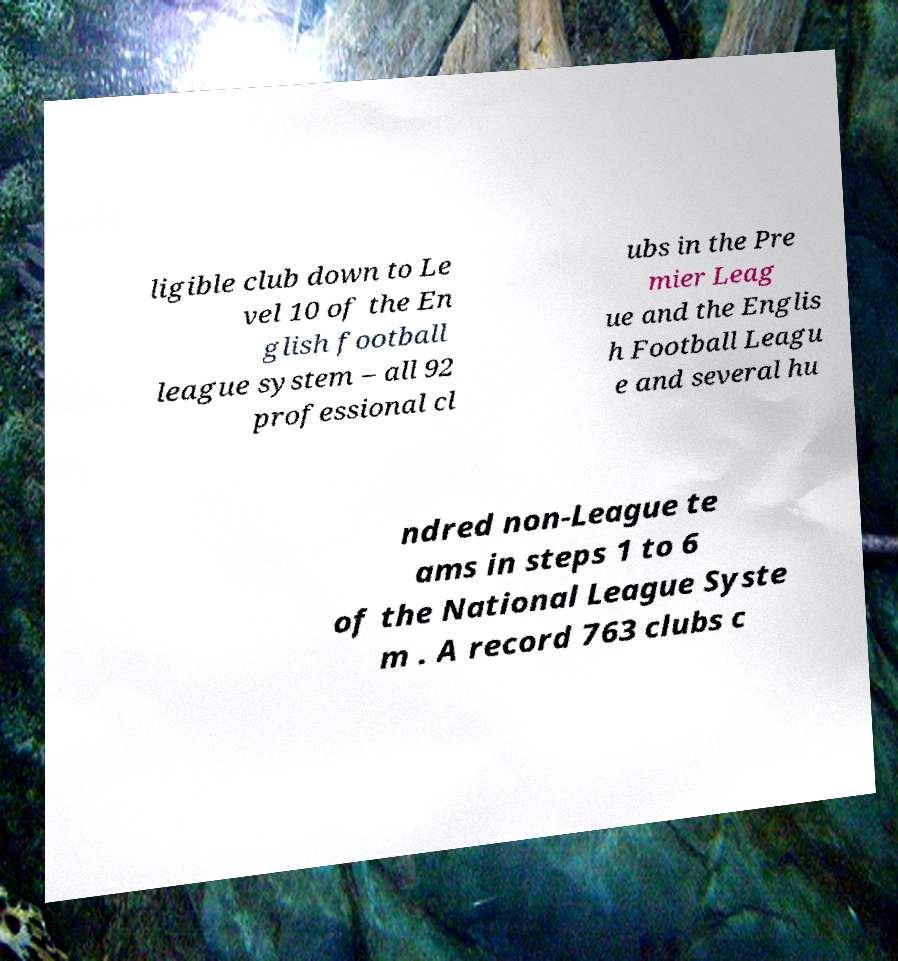Could you assist in decoding the text presented in this image and type it out clearly? ligible club down to Le vel 10 of the En glish football league system – all 92 professional cl ubs in the Pre mier Leag ue and the Englis h Football Leagu e and several hu ndred non-League te ams in steps 1 to 6 of the National League Syste m . A record 763 clubs c 